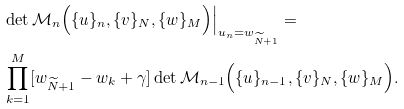<formula> <loc_0><loc_0><loc_500><loc_500>& \det \mathcal { M } _ { n } \Big ( \{ u \} _ { n } , \{ v \} _ { N } , \{ w \} _ { M } \Big ) \Big | _ { u _ { n } = w _ { \widetilde { N } + 1 } } = \\ & \prod _ { k = 1 } ^ { M } [ w _ { \widetilde { N } + 1 } - w _ { k } + \gamma ] \det \mathcal { M } _ { n - 1 } \Big ( \{ u \} _ { n - 1 } , \{ v \} _ { N } , \{ w \} _ { M } \Big ) .</formula> 